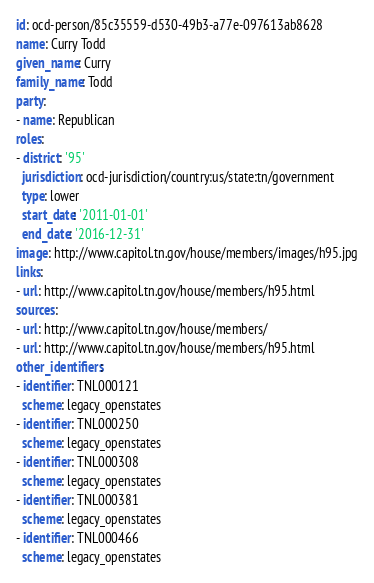Convert code to text. <code><loc_0><loc_0><loc_500><loc_500><_YAML_>id: ocd-person/85c35559-d530-49b3-a77e-097613ab8628
name: Curry Todd
given_name: Curry
family_name: Todd
party:
- name: Republican
roles:
- district: '95'
  jurisdiction: ocd-jurisdiction/country:us/state:tn/government
  type: lower
  start_date: '2011-01-01'
  end_date: '2016-12-31'
image: http://www.capitol.tn.gov/house/members/images/h95.jpg
links:
- url: http://www.capitol.tn.gov/house/members/h95.html
sources:
- url: http://www.capitol.tn.gov/house/members/
- url: http://www.capitol.tn.gov/house/members/h95.html
other_identifiers:
- identifier: TNL000121
  scheme: legacy_openstates
- identifier: TNL000250
  scheme: legacy_openstates
- identifier: TNL000308
  scheme: legacy_openstates
- identifier: TNL000381
  scheme: legacy_openstates
- identifier: TNL000466
  scheme: legacy_openstates
</code> 